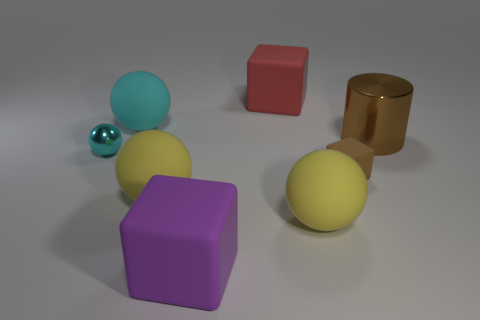There is a block that is in front of the tiny rubber cube; what is it made of?
Give a very brief answer. Rubber. Is the number of big cyan things that are in front of the purple rubber thing less than the number of blue matte cylinders?
Give a very brief answer. No. Is the shape of the tiny cyan metal thing the same as the big cyan thing?
Offer a terse response. Yes. Is there anything else that is the same shape as the brown metallic object?
Offer a terse response. No. Are any blue rubber spheres visible?
Provide a succinct answer. No. There is a small brown rubber thing; is its shape the same as the purple object in front of the tiny brown block?
Make the answer very short. Yes. There is a cyan object that is behind the metallic thing right of the large cyan rubber object; what is its material?
Your response must be concise. Rubber. The cylinder has what color?
Keep it short and to the point. Brown. Is the color of the matte cube to the right of the red block the same as the big shiny cylinder that is in front of the red matte thing?
Ensure brevity in your answer.  Yes. The red thing that is the same shape as the purple thing is what size?
Keep it short and to the point. Large. 